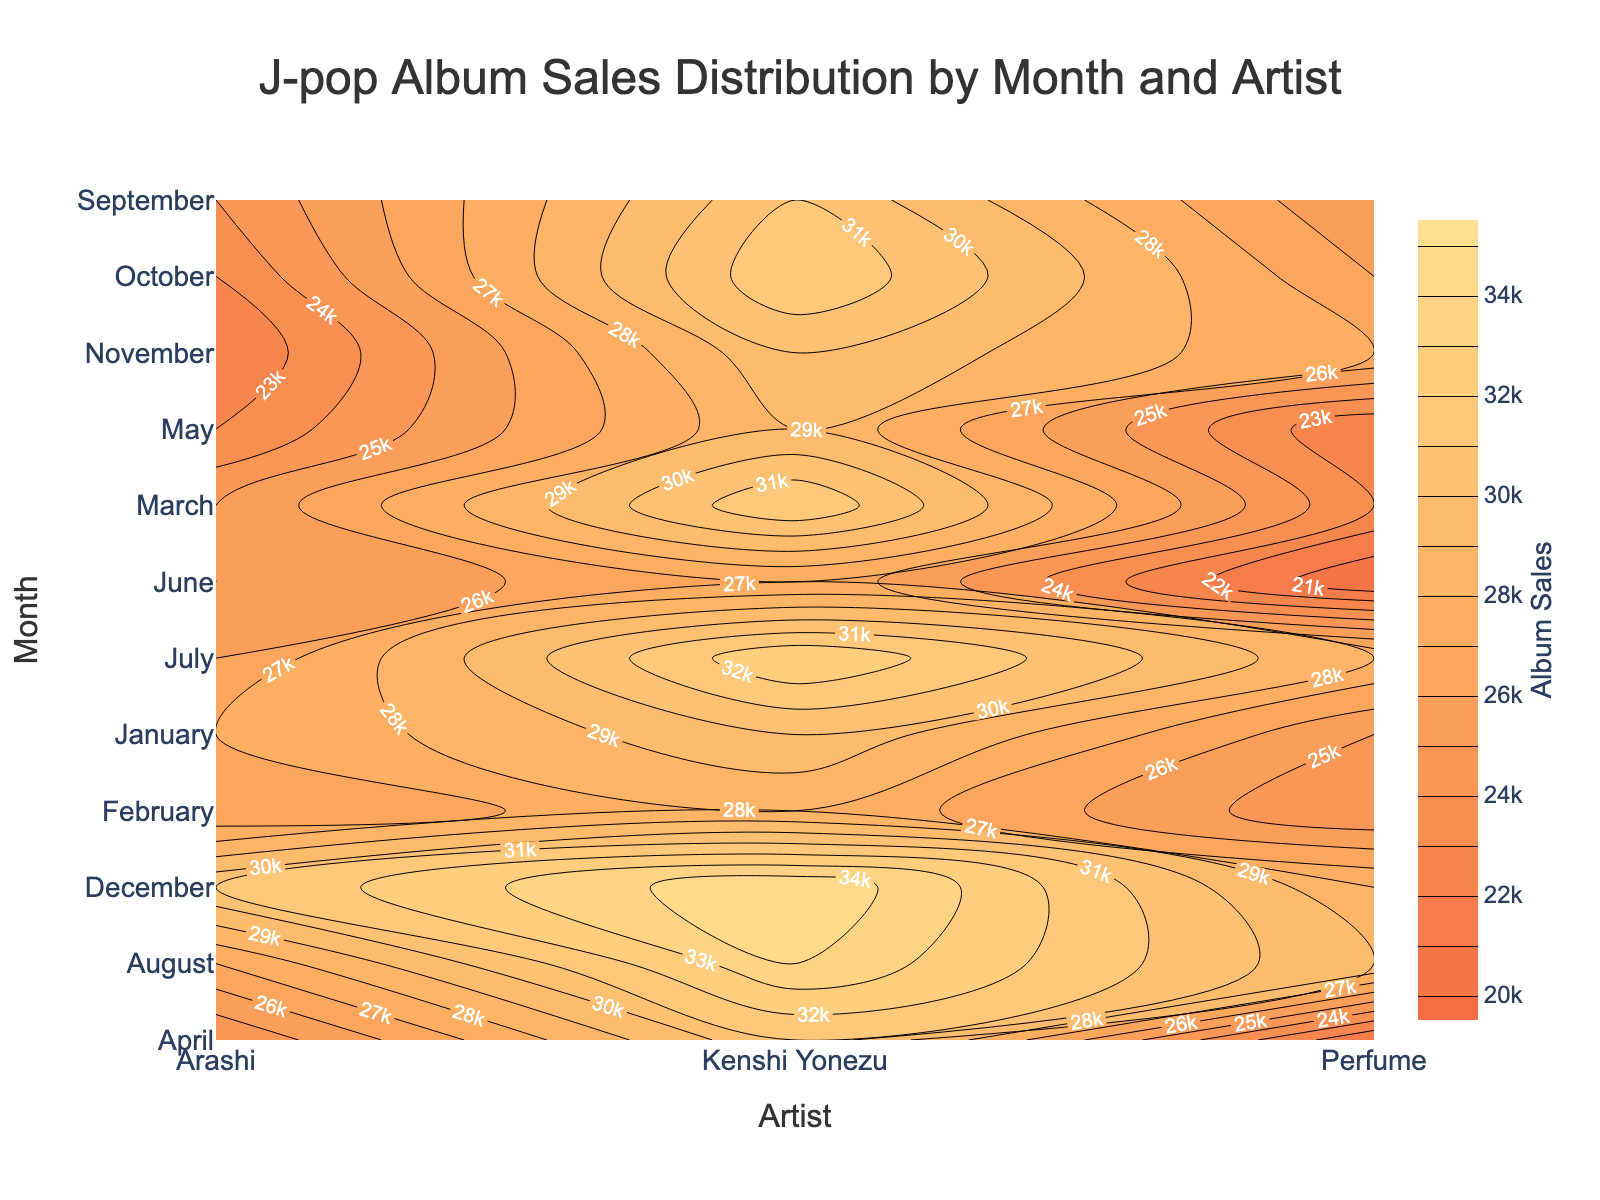What is the title of the plot? The title is usually situated at the top of the plot, and in this case, it reads "J-pop Album Sales Distribution by Month and Artist". The title helps to quickly identify what the plot is about.
Answer: J-pop Album Sales Distribution by Month and Artist Which artist had the highest album sales in December? To find this, you look at the contour values in December (y-axis), and see which artist (x-axis) reached the highest value. Kenshi Yonezu shows 35,000 in December.
Answer: Kenshi Yonezu In which month did Perfume achieve their highest album sales? By examining the contour values corresponding to Perfume across all months, we pinpoint July and August as the months with highest value at 28,000 and 29,000 respectively. Among them, August holds the highest.
Answer: August During which month did Kenshi Yonezu's album sales peak? Kenshi Yonezu's highest value on the contour plot occurs at the value 35,000 corresponding to the month of December. You can cross-check this by looking at the y-axis values.
Answer: December By how much did Arashi's album sales increase from October to December? Comparing the contour value for Arashi in October (23,000) and December (31,000), subtract October's value from December's value: 31,000 - 23,000 = 8,000.
Answer: 8,000 How do the album sales of Arashi in June compare to their sales in July? The contour values show that Arashi's sales were 25,000 in June and increased slightly to 26,000 in July. So the sales increased from June to July.
Answer: Increased Which artist shows a decreasing trend in album sales from January to April? Observing the contour values for each artist individually for the months from January to April reveals that Perfume's values decrease from 25,000 (January) to 21,000 (April).
Answer: Perfume What is the average album sales for Kenshi Yonezu across all the months? Summing Kenshi Yonezu's contour values across all months (30000 + 28000 + 32000 + 31000 + 29000 + 27000 + 33000 + 34000 + 31000 + 32000 + 30000 + 35000) amounts to 391000. Dividing this sum over 12 months results in an average of 32,583.33.
Answer: 32,583.33 During which month did Perfume record their lowest album sales and what was the sales figure? Identifying the minimum contour value for Perfume across all months shows May and June both having the lowest value of 20,000 and 21,000 respectively, with June being the lowest.
Answer: June, 20,000 Which month had the most significant overall album sales for all three artists combined? To find this, you add up the album sales for each artist across every month and compare. December sums up to the highest total (35000 + 28000 + 31000 = 94000).
Answer: December 